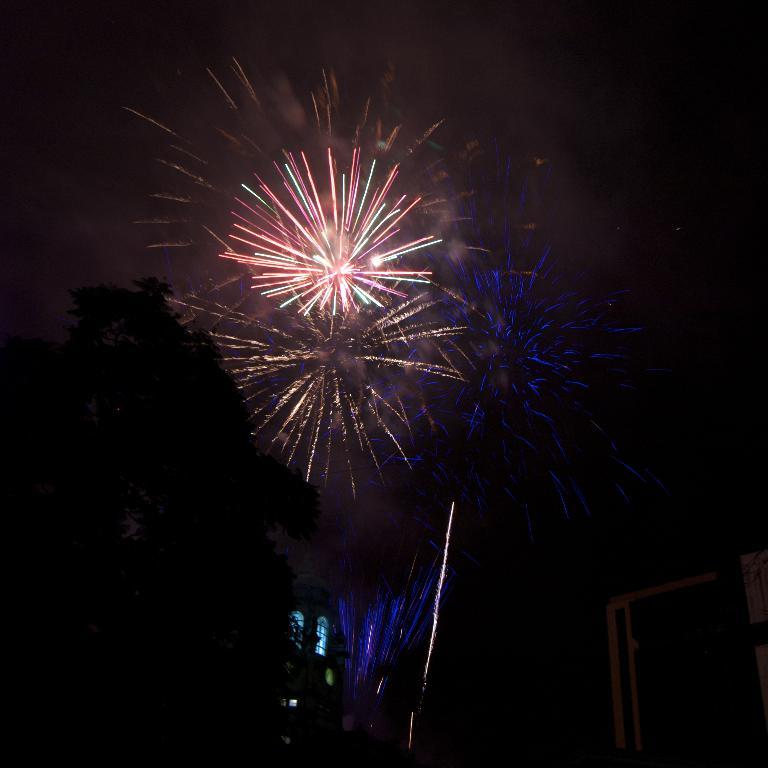What type of structures can be seen in the image? There are buildings in the image. What else is visible in the image besides the buildings? There are lights and trees visible in the image. What is the color of the sky in the background of the image? The sky is dark in the background of the image. What additional feature can be seen in the background of the image? There are exploding fireworks in the background of the image. What type of toys can be seen on the ground in the image? There are no toys present in the image; it features buildings, lights, trees, a dark sky, and exploding fireworks. 